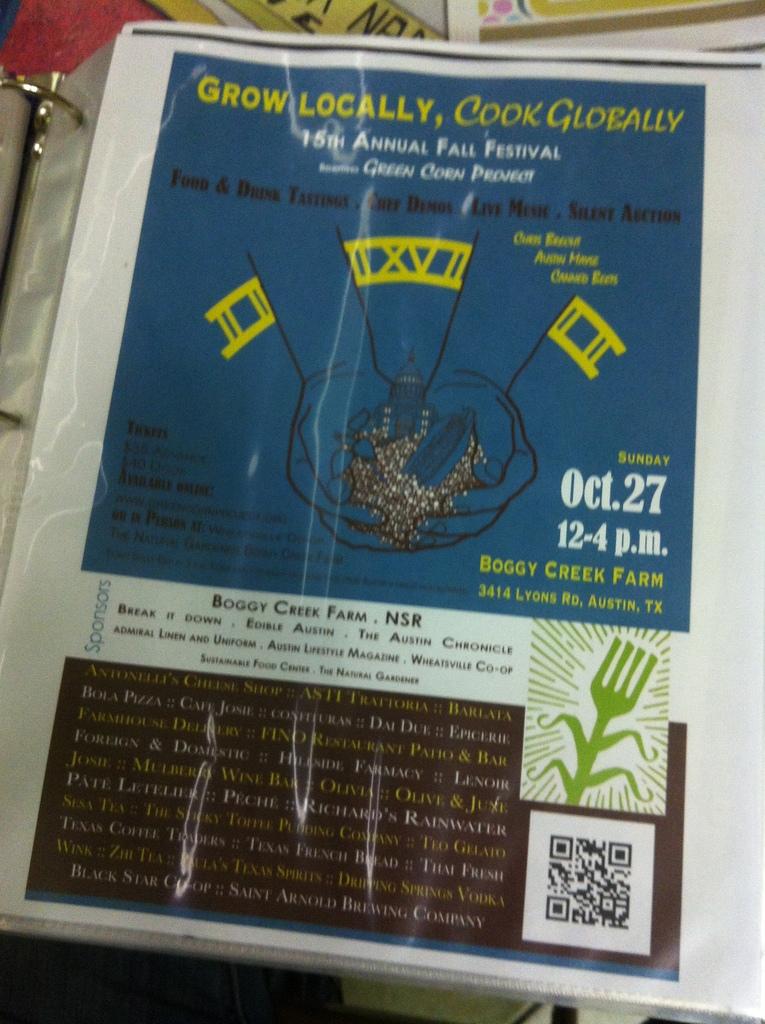What is the name of the event?
Your answer should be compact. 15th annual fall festival. What is the date of the event?
Provide a short and direct response. Oct. 27. 